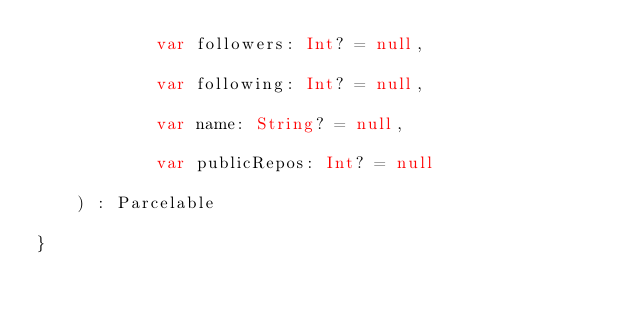<code> <loc_0><loc_0><loc_500><loc_500><_Kotlin_>            var followers: Int? = null,

            var following: Int? = null,

            var name: String? = null,

            var publicRepos: Int? = null

    ) : Parcelable

}</code> 